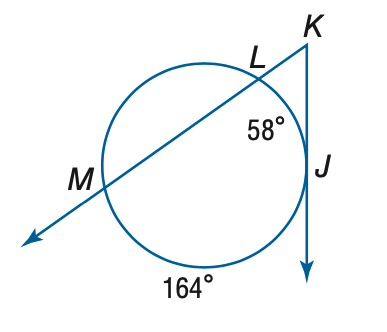Answer the mathemtical geometry problem and directly provide the correct option letter.
Question: Find the measure of m \angle K.
Choices: A: 26.5 B: 53 C: 58 D: 106 B 